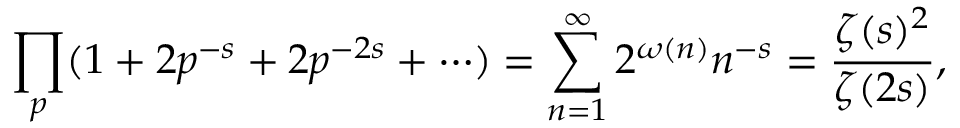Convert formula to latex. <formula><loc_0><loc_0><loc_500><loc_500>\prod _ { p } ( 1 + 2 p ^ { - s } + 2 p ^ { - 2 s } + \cdots ) = \sum _ { n = 1 } ^ { \infty } 2 ^ { \omega ( n ) } n ^ { - s } = { \frac { \zeta ( s ) ^ { 2 } } { \zeta ( 2 s ) } } ,</formula> 